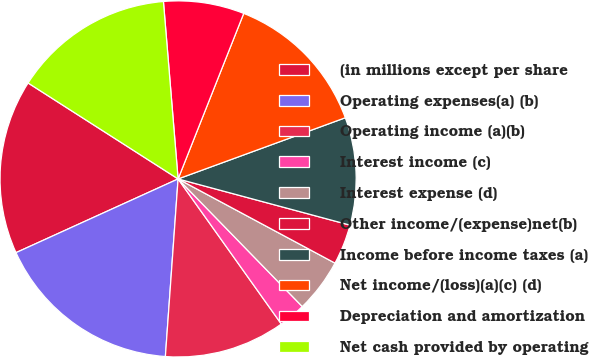<chart> <loc_0><loc_0><loc_500><loc_500><pie_chart><fcel>(in millions except per share<fcel>Operating expenses(a) (b)<fcel>Operating income (a)(b)<fcel>Interest income (c)<fcel>Interest expense (d)<fcel>Other income/(expense)net(b)<fcel>Income before income taxes (a)<fcel>Net income/(loss)(a)(c) (d)<fcel>Depreciation and amortization<fcel>Net cash provided by operating<nl><fcel>15.85%<fcel>17.07%<fcel>10.98%<fcel>2.44%<fcel>4.88%<fcel>3.66%<fcel>9.76%<fcel>13.41%<fcel>7.32%<fcel>14.63%<nl></chart> 